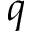<formula> <loc_0><loc_0><loc_500><loc_500>q</formula> 